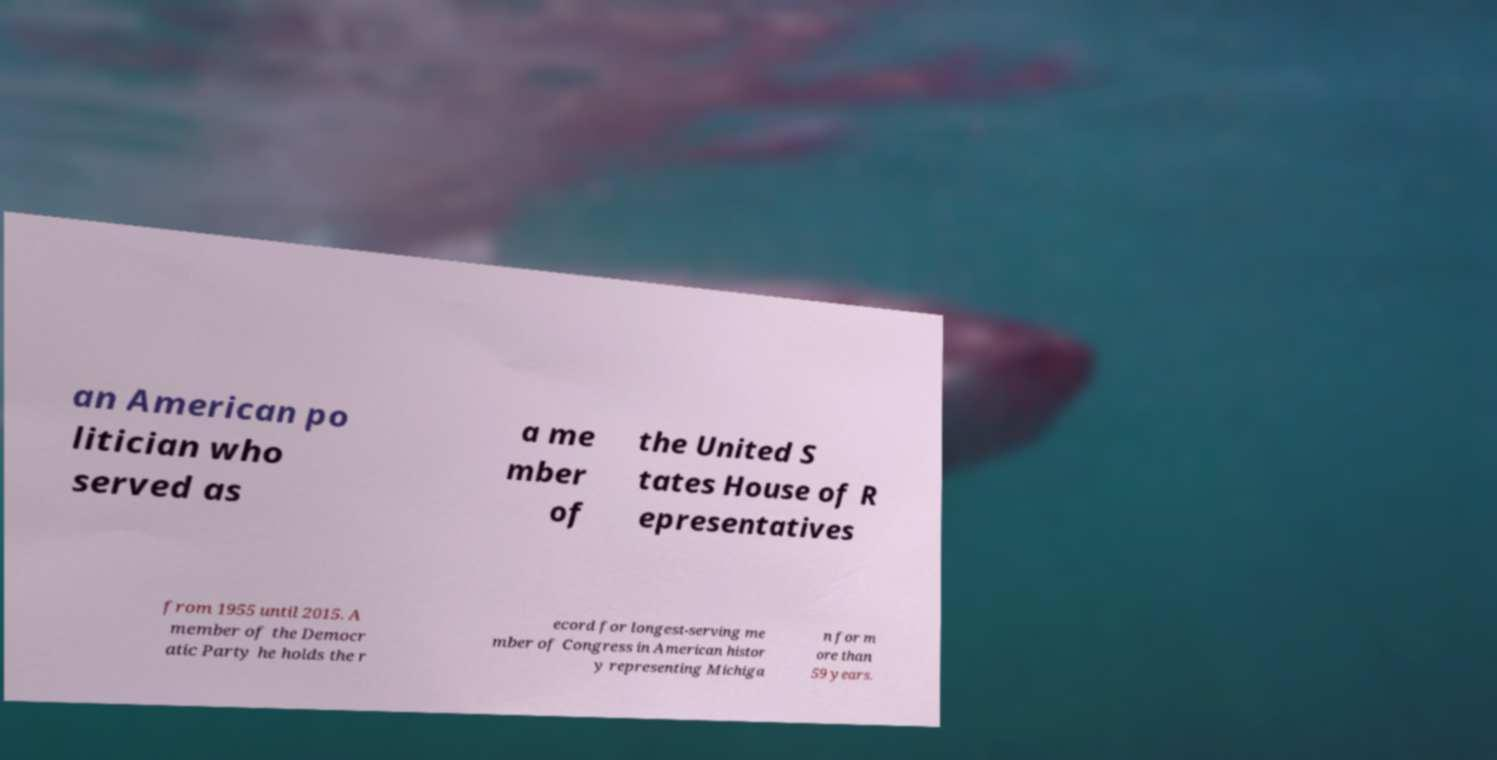Please identify and transcribe the text found in this image. an American po litician who served as a me mber of the United S tates House of R epresentatives from 1955 until 2015. A member of the Democr atic Party he holds the r ecord for longest-serving me mber of Congress in American histor y representing Michiga n for m ore than 59 years. 